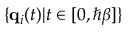<formula> <loc_0><loc_0><loc_500><loc_500>\{ q _ { i } ( t ) | t \in [ 0 , \hbar { \beta } ] \}</formula> 